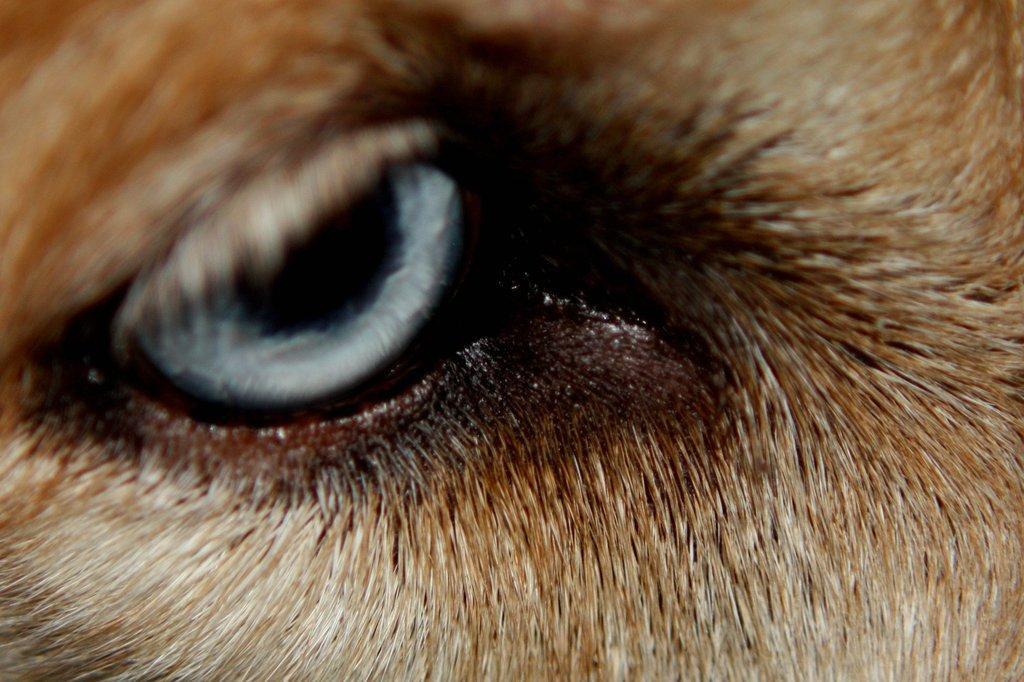Please provide a concise description of this image. In this picture I can see an animal eye. 